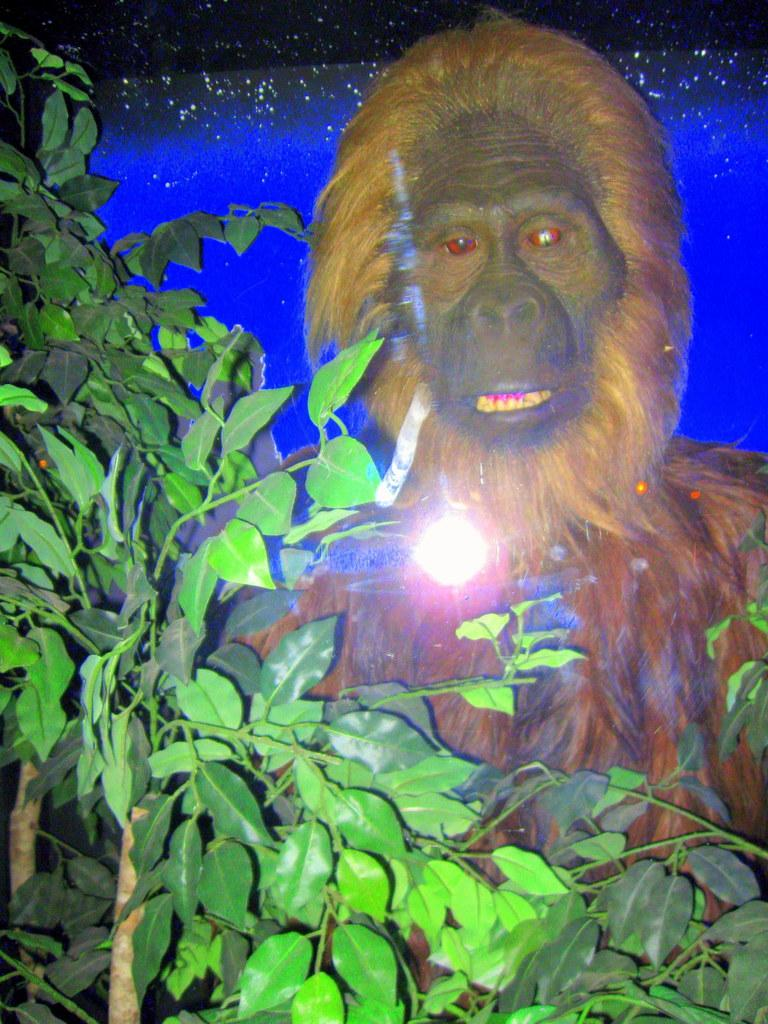What is the main subject of the image? There is a statue of an animal in the image. What is located in front of the statue? There are plants in front of the statue. Can you describe the background of the image? The background of the image has blue and black colors. What type of mask is the animal wearing in the image? There is no mask present on the animal in the image. What learning material can be seen near the statue? There is no learning material visible in the image. 